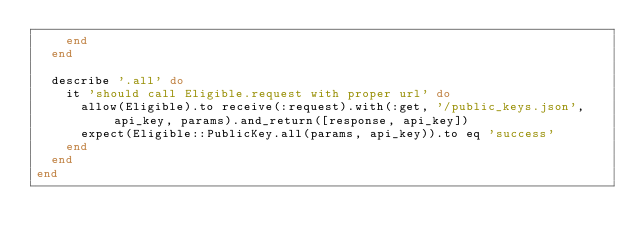<code> <loc_0><loc_0><loc_500><loc_500><_Ruby_>    end
  end

  describe '.all' do
    it 'should call Eligible.request with proper url' do
      allow(Eligible).to receive(:request).with(:get, '/public_keys.json', api_key, params).and_return([response, api_key])
      expect(Eligible::PublicKey.all(params, api_key)).to eq 'success'
    end
  end
end
</code> 